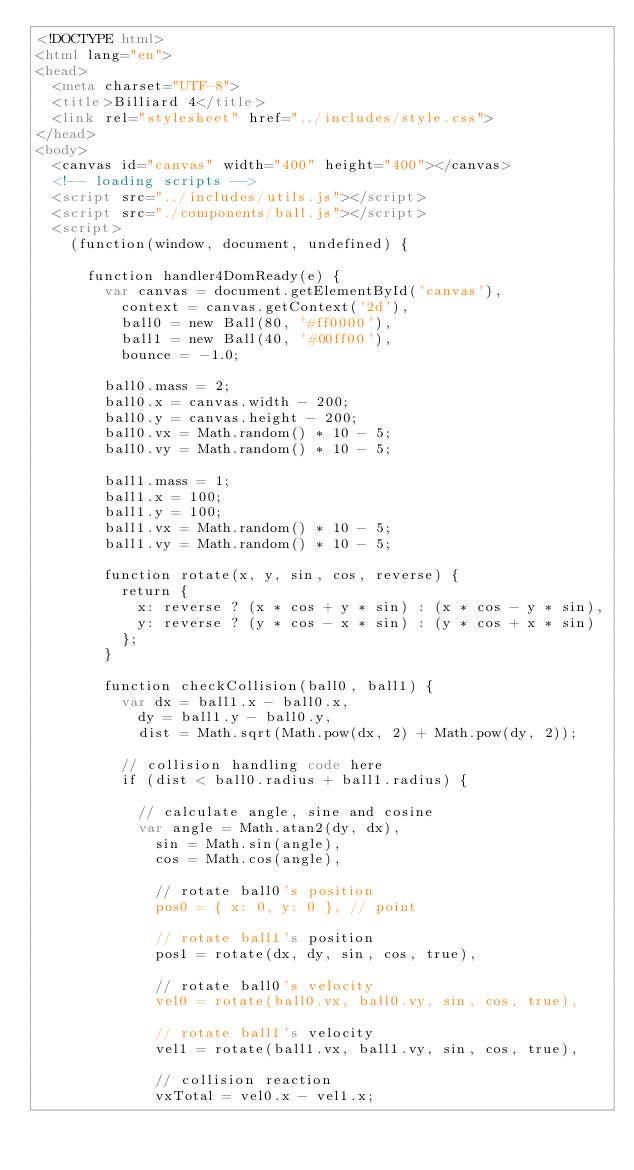<code> <loc_0><loc_0><loc_500><loc_500><_HTML_><!DOCTYPE html>
<html lang="en">
<head>
  <meta charset="UTF-8">
  <title>Billiard 4</title>
  <link rel="stylesheet" href="../includes/style.css">
</head>
<body>
  <canvas id="canvas" width="400" height="400"></canvas>
  <!-- loading scripts -->
  <script src="../includes/utils.js"></script>
  <script src="./components/ball.js"></script>
  <script>
    (function(window, document, undefined) {

      function handler4DomReady(e) {
        var canvas = document.getElementById('canvas'),
          context = canvas.getContext('2d'),
          ball0 = new Ball(80, '#ff0000'),
          ball1 = new Ball(40, '#00ff00'),
          bounce = -1.0;

        ball0.mass = 2;
        ball0.x = canvas.width - 200;
        ball0.y = canvas.height - 200;
        ball0.vx = Math.random() * 10 - 5;
        ball0.vy = Math.random() * 10 - 5;

        ball1.mass = 1;
        ball1.x = 100;
        ball1.y = 100;
        ball1.vx = Math.random() * 10 - 5;
        ball1.vy = Math.random() * 10 - 5;

        function rotate(x, y, sin, cos, reverse) {
          return {
            x: reverse ? (x * cos + y * sin) : (x * cos - y * sin),
            y: reverse ? (y * cos - x * sin) : (y * cos + x * sin)
          };
        }

        function checkCollision(ball0, ball1) {
          var dx = ball1.x - ball0.x,
            dy = ball1.y - ball0.y,
            dist = Math.sqrt(Math.pow(dx, 2) + Math.pow(dy, 2));
          
          // collision handling code here
          if (dist < ball0.radius + ball1.radius) {

            // calculate angle, sine and cosine
            var angle = Math.atan2(dy, dx),
              sin = Math.sin(angle),
              cos = Math.cos(angle),

              // rotate ball0's position
              pos0 = { x: 0, y: 0 }, // point

              // rotate ball1's position
              pos1 = rotate(dx, dy, sin, cos, true),

              // rotate ball0's velocity
              vel0 = rotate(ball0.vx, ball0.vy, sin, cos, true),

              // rotate ball1's velocity
              vel1 = rotate(ball1.vx, ball1.vy, sin, cos, true),

              // collision reaction
              vxTotal = vel0.x - vel1.x;
</code> 